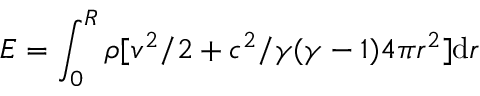<formula> <loc_0><loc_0><loc_500><loc_500>E = \int _ { 0 } ^ { R } \rho [ v ^ { 2 } / 2 + c ^ { 2 } / \gamma ( \gamma - 1 ) 4 \pi r ^ { 2 } ] d r</formula> 